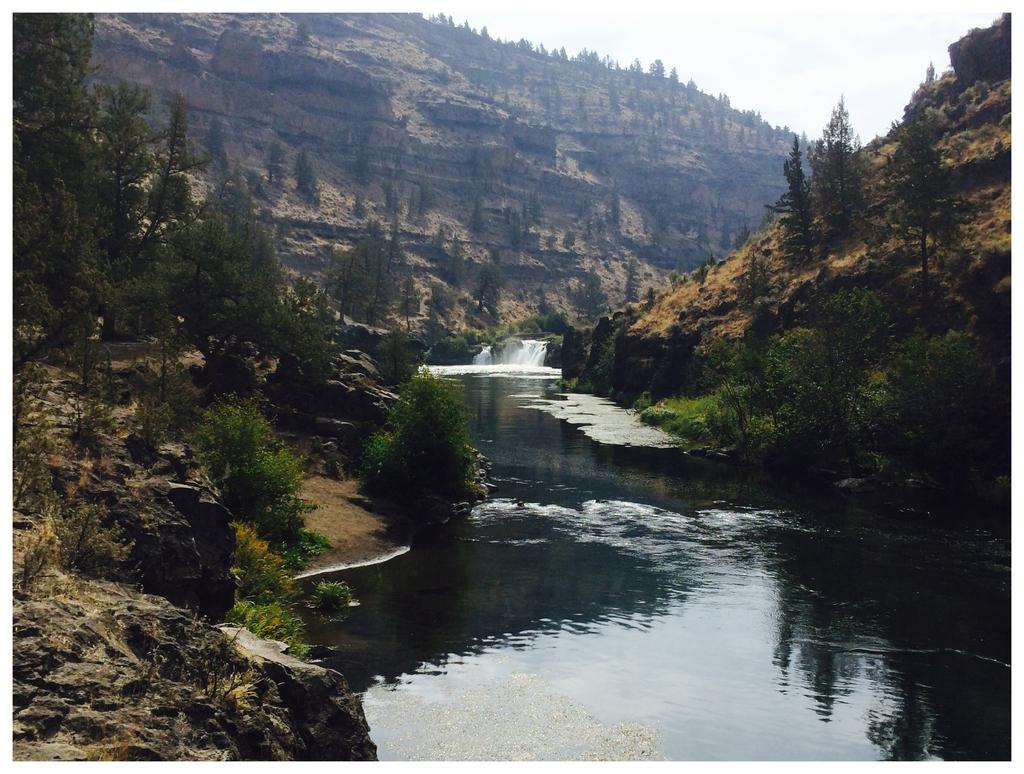What is visible at the bottom of the image? There is water visible at the bottom of the image. What type of vegetation can be seen on the left side of the image? There are trees on the ground on the left side of the image. What type of geological feature is visible in the image? There are rocks visible in the image. What can be seen in the background of the image? There are trees on a mountain and the sky visible in the background of the image. How much tax is being charged on the rocks in the image? There is no mention of tax or any financial transaction in the image, as it primarily features natural elements such as water, trees, and rocks. --- Facts: 1. There is a person sitting on a bench in the image. 2. The person is reading a book. 3. There is a tree behind the bench. 4. The ground is visible in the image. 5. There is a fence in the background of the image. Absurd Topics: parrot, bicycle, ocean Conversation: What is the person in the image doing? The person is sitting on a bench and reading a book. What type of object is behind the bench? There is a tree behind the bench. What can be seen on the ground in the image? The ground is visible in the image. What architectural feature is present in the background of the image? There is a fence in the background of the image. Reasoning: Let's think step by step in order to produce the conversation. We start by identifying the main subject in the image, which is the person sitting on the bench. Then, we expand the conversation to include the person's activity (reading a book) and the surrounding environment, such as the tree, the ground, and the fence. Each question is designed to elicit a specific detail about the image that is known from the provided facts. Absurd Question/Answer: Can you tell me how many parrots are sitting on the fence in the image? There are no parrots present in the image; it primarily features a person reading a book, a tree, the ground, and a fence. 